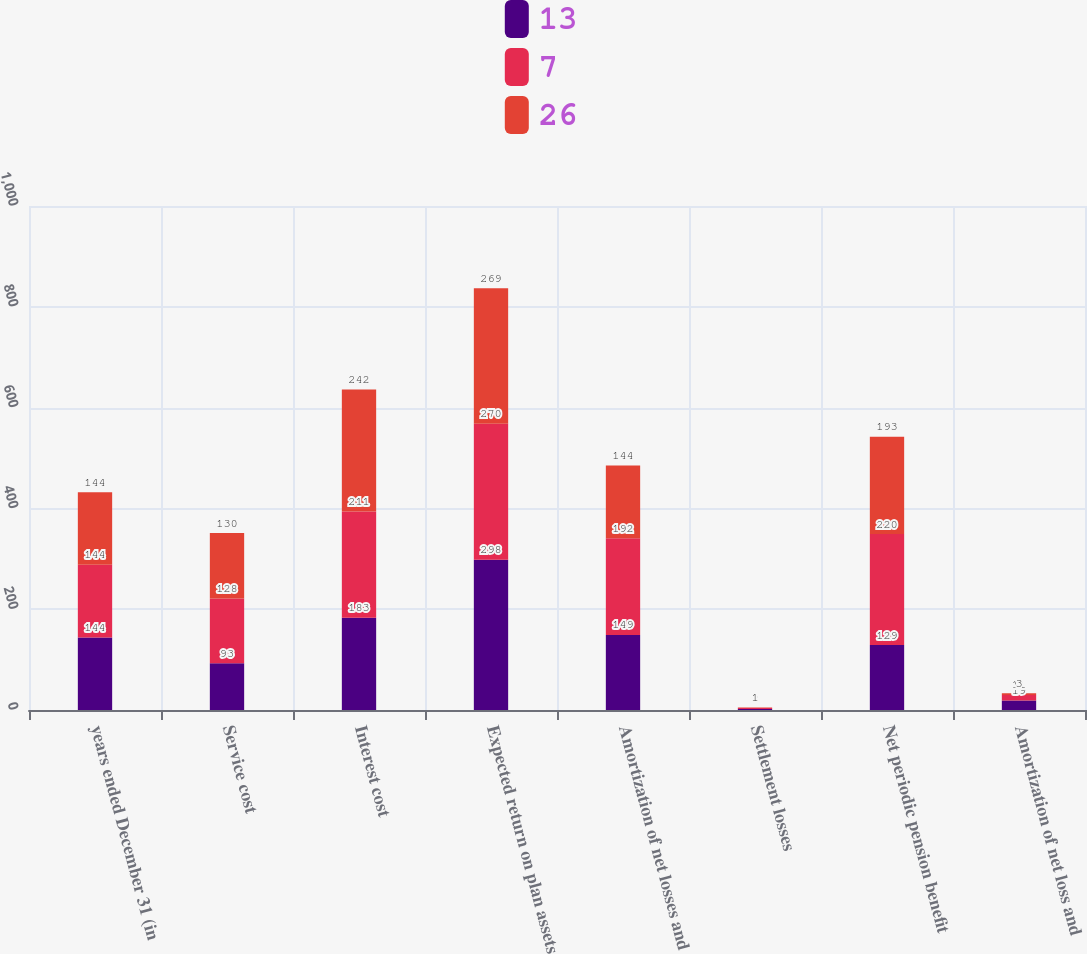Convert chart. <chart><loc_0><loc_0><loc_500><loc_500><stacked_bar_chart><ecel><fcel>years ended December 31 (in<fcel>Service cost<fcel>Interest cost<fcel>Expected return on plan assets<fcel>Amortization of net losses and<fcel>Settlement losses<fcel>Net periodic pension benefit<fcel>Amortization of net loss and<nl><fcel>13<fcel>144<fcel>93<fcel>183<fcel>298<fcel>149<fcel>2<fcel>129<fcel>19<nl><fcel>7<fcel>144<fcel>128<fcel>211<fcel>270<fcel>192<fcel>2<fcel>220<fcel>11<nl><fcel>26<fcel>144<fcel>130<fcel>242<fcel>269<fcel>144<fcel>1<fcel>193<fcel>3<nl></chart> 